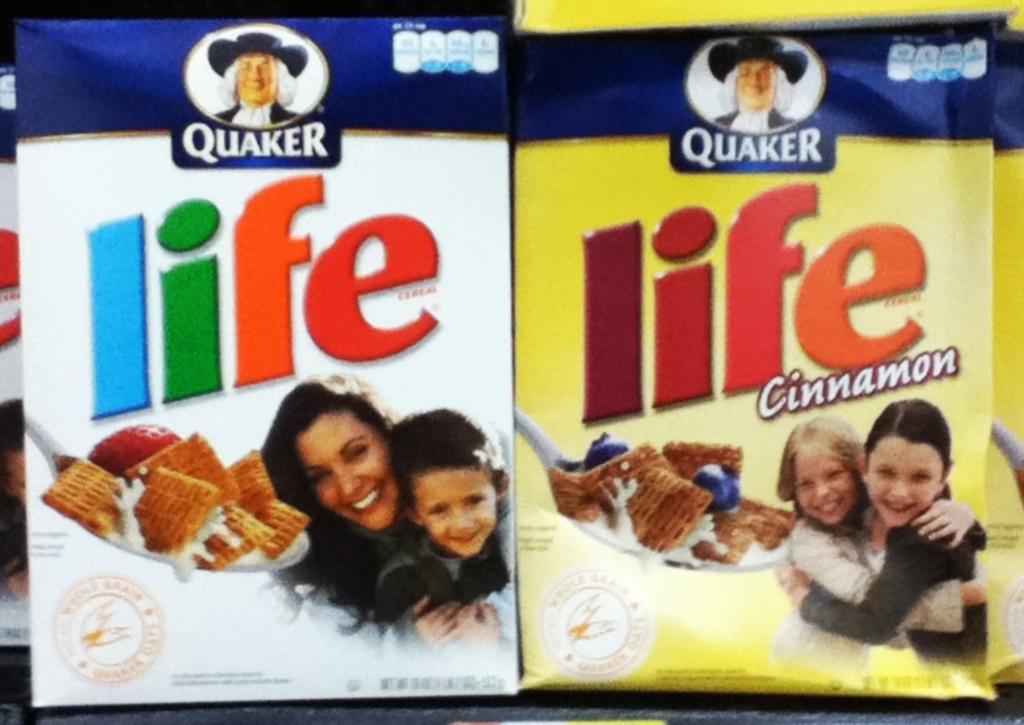What objects are present in the image? There are packets in the image. Can you describe the packets in the image? Unfortunately, the provided facts do not give any details about the packets, so we cannot describe them further. What type of scent can be smelled coming from the mitten in the image? There is no mitten present in the image, so it is not possible to determine any scent associated with it. 